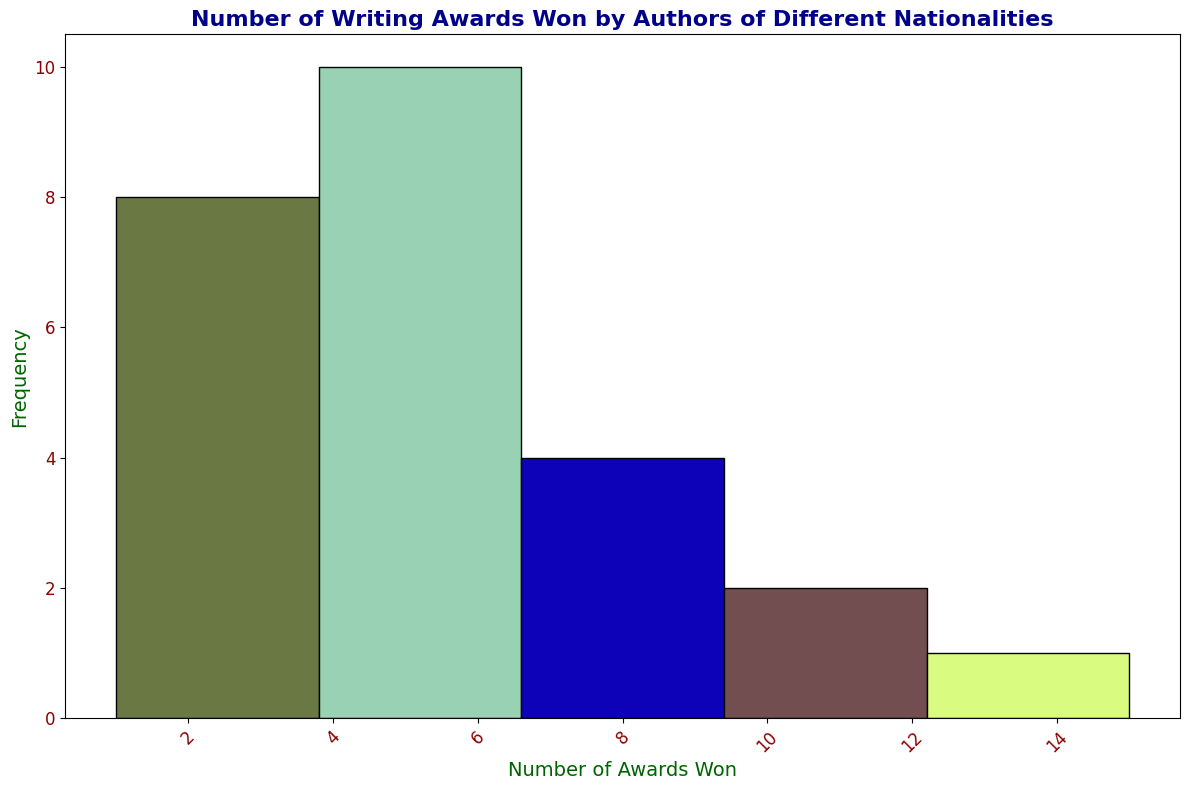How many nationalities have authors who have won exactly 4 awards? Look at the histogram and count the bars that represent the number 4 on the x-axis. The height of these bars will give the frequency.
Answer: 4 Which nationality's authors have the highest number of awards? Find the bar with the greatest x-axis value and see the corresponding label in the histogram. The frequency of the highest bar shows the country.
Answer: British How many nationalities have authors who have won 2 awards? Identify the bar corresponding to 2 awards on the x-axis and count the frequency of this bar.
Answer: 3 Are there more nationalities with authors who have won fewer than 5 awards or more than 5 awards? Count the bars representing values less than 5 on the x-axis and separately count those with values greater than 5. Compare these two sums to find which is higher.
Answer: More than 5 awards What is the total number of awards won by authors from nationalities who have 1 or 2 awards? To get the total sum for these two bars, multiply the frequency of the bar representing 1 award by 1, then multiply the frequency of the bar representing 2 awards by 2, and add both quantities.
Answer: 7 What is the most common number of awards won by authors? Identify the tallest bar (highest frequency) on the histogram and see which x-axis value it corresponds to.
Answer: 4 How many nationalities have authors that won between 3 and 6 awards, inclusive? Count all the bars on the histogram that fall between 3 and 6 on the x-axis and sum their frequencies.
Answer: 10 Compare the frequencies of authors winning 3 awards and those winning 5 awards. Which is higher? Locate the bars representing 3 and 5 awards on the x-axis and compare their heights.
Answer: 5 awards What is the total number of nationalities represented in the histogram? Count all the individual bars on the histogram, each representing different nationalities.
Answer: 25 